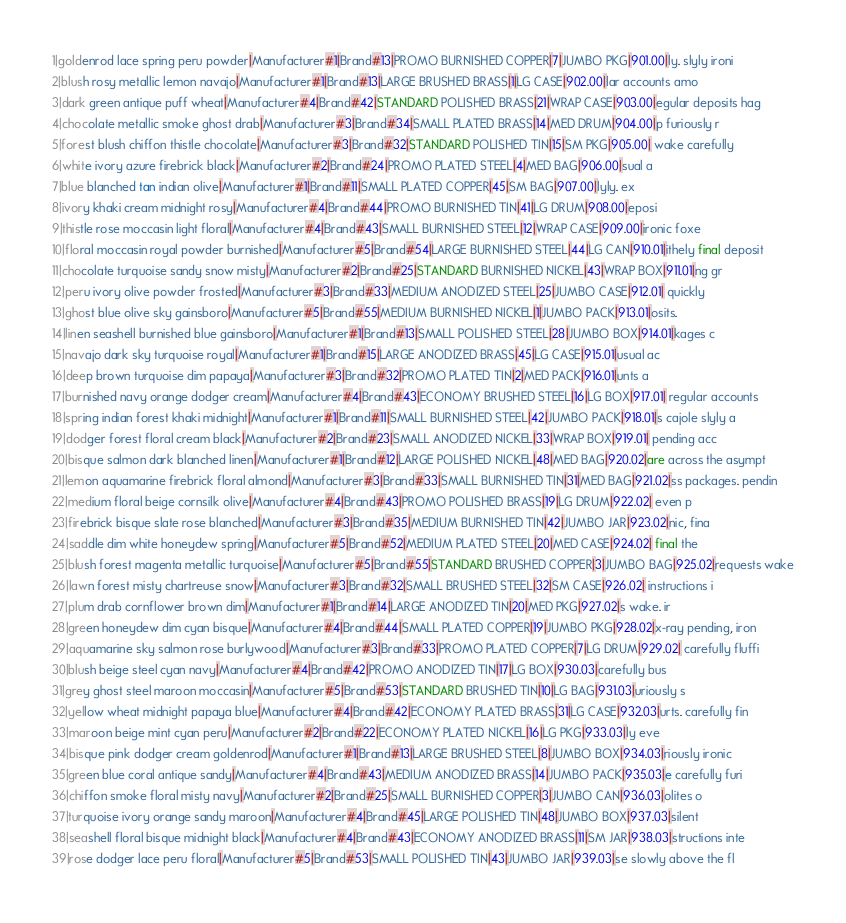<code> <loc_0><loc_0><loc_500><loc_500><_COBOL_>1|goldenrod lace spring peru powder|Manufacturer#1|Brand#13|PROMO BURNISHED COPPER|7|JUMBO PKG|901.00|ly. slyly ironi
2|blush rosy metallic lemon navajo|Manufacturer#1|Brand#13|LARGE BRUSHED BRASS|1|LG CASE|902.00|lar accounts amo
3|dark green antique puff wheat|Manufacturer#4|Brand#42|STANDARD POLISHED BRASS|21|WRAP CASE|903.00|egular deposits hag
4|chocolate metallic smoke ghost drab|Manufacturer#3|Brand#34|SMALL PLATED BRASS|14|MED DRUM|904.00|p furiously r
5|forest blush chiffon thistle chocolate|Manufacturer#3|Brand#32|STANDARD POLISHED TIN|15|SM PKG|905.00| wake carefully 
6|white ivory azure firebrick black|Manufacturer#2|Brand#24|PROMO PLATED STEEL|4|MED BAG|906.00|sual a
7|blue blanched tan indian olive|Manufacturer#1|Brand#11|SMALL PLATED COPPER|45|SM BAG|907.00|lyly. ex
8|ivory khaki cream midnight rosy|Manufacturer#4|Brand#44|PROMO BURNISHED TIN|41|LG DRUM|908.00|eposi
9|thistle rose moccasin light floral|Manufacturer#4|Brand#43|SMALL BURNISHED STEEL|12|WRAP CASE|909.00|ironic foxe
10|floral moccasin royal powder burnished|Manufacturer#5|Brand#54|LARGE BURNISHED STEEL|44|LG CAN|910.01|ithely final deposit
11|chocolate turquoise sandy snow misty|Manufacturer#2|Brand#25|STANDARD BURNISHED NICKEL|43|WRAP BOX|911.01|ng gr
12|peru ivory olive powder frosted|Manufacturer#3|Brand#33|MEDIUM ANODIZED STEEL|25|JUMBO CASE|912.01| quickly
13|ghost blue olive sky gainsboro|Manufacturer#5|Brand#55|MEDIUM BURNISHED NICKEL|1|JUMBO PACK|913.01|osits.
14|linen seashell burnished blue gainsboro|Manufacturer#1|Brand#13|SMALL POLISHED STEEL|28|JUMBO BOX|914.01|kages c
15|navajo dark sky turquoise royal|Manufacturer#1|Brand#15|LARGE ANODIZED BRASS|45|LG CASE|915.01|usual ac
16|deep brown turquoise dim papaya|Manufacturer#3|Brand#32|PROMO PLATED TIN|2|MED PACK|916.01|unts a
17|burnished navy orange dodger cream|Manufacturer#4|Brand#43|ECONOMY BRUSHED STEEL|16|LG BOX|917.01| regular accounts
18|spring indian forest khaki midnight|Manufacturer#1|Brand#11|SMALL BURNISHED STEEL|42|JUMBO PACK|918.01|s cajole slyly a
19|dodger forest floral cream black|Manufacturer#2|Brand#23|SMALL ANODIZED NICKEL|33|WRAP BOX|919.01| pending acc
20|bisque salmon dark blanched linen|Manufacturer#1|Brand#12|LARGE POLISHED NICKEL|48|MED BAG|920.02|are across the asympt
21|lemon aquamarine firebrick floral almond|Manufacturer#3|Brand#33|SMALL BURNISHED TIN|31|MED BAG|921.02|ss packages. pendin
22|medium floral beige cornsilk olive|Manufacturer#4|Brand#43|PROMO POLISHED BRASS|19|LG DRUM|922.02| even p
23|firebrick bisque slate rose blanched|Manufacturer#3|Brand#35|MEDIUM BURNISHED TIN|42|JUMBO JAR|923.02|nic, fina
24|saddle dim white honeydew spring|Manufacturer#5|Brand#52|MEDIUM PLATED STEEL|20|MED CASE|924.02| final the
25|blush forest magenta metallic turquoise|Manufacturer#5|Brand#55|STANDARD BRUSHED COPPER|3|JUMBO BAG|925.02|requests wake
26|lawn forest misty chartreuse snow|Manufacturer#3|Brand#32|SMALL BRUSHED STEEL|32|SM CASE|926.02| instructions i
27|plum drab cornflower brown dim|Manufacturer#1|Brand#14|LARGE ANODIZED TIN|20|MED PKG|927.02|s wake. ir
28|green honeydew dim cyan bisque|Manufacturer#4|Brand#44|SMALL PLATED COPPER|19|JUMBO PKG|928.02|x-ray pending, iron
29|aquamarine sky salmon rose burlywood|Manufacturer#3|Brand#33|PROMO PLATED COPPER|7|LG DRUM|929.02| carefully fluffi
30|blush beige steel cyan navy|Manufacturer#4|Brand#42|PROMO ANODIZED TIN|17|LG BOX|930.03|carefully bus
31|grey ghost steel maroon moccasin|Manufacturer#5|Brand#53|STANDARD BRUSHED TIN|10|LG BAG|931.03|uriously s
32|yellow wheat midnight papaya blue|Manufacturer#4|Brand#42|ECONOMY PLATED BRASS|31|LG CASE|932.03|urts. carefully fin
33|maroon beige mint cyan peru|Manufacturer#2|Brand#22|ECONOMY PLATED NICKEL|16|LG PKG|933.03|ly eve
34|bisque pink dodger cream goldenrod|Manufacturer#1|Brand#13|LARGE BRUSHED STEEL|8|JUMBO BOX|934.03|riously ironic
35|green blue coral antique sandy|Manufacturer#4|Brand#43|MEDIUM ANODIZED BRASS|14|JUMBO PACK|935.03|e carefully furi
36|chiffon smoke floral misty navy|Manufacturer#2|Brand#25|SMALL BURNISHED COPPER|3|JUMBO CAN|936.03|olites o
37|turquoise ivory orange sandy maroon|Manufacturer#4|Brand#45|LARGE POLISHED TIN|48|JUMBO BOX|937.03|silent 
38|seashell floral bisque midnight black|Manufacturer#4|Brand#43|ECONOMY ANODIZED BRASS|11|SM JAR|938.03|structions inte
39|rose dodger lace peru floral|Manufacturer#5|Brand#53|SMALL POLISHED TIN|43|JUMBO JAR|939.03|se slowly above the fl</code> 